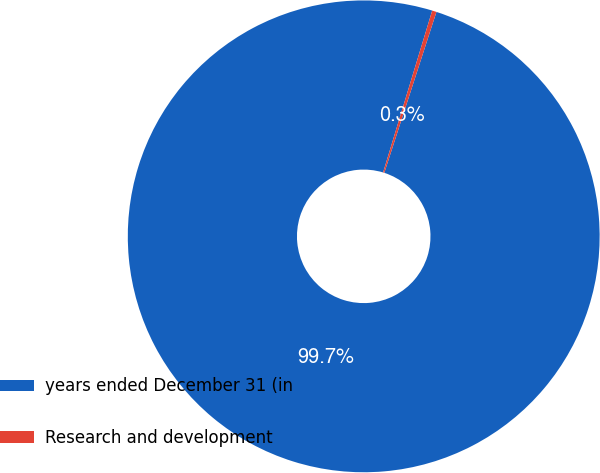Convert chart. <chart><loc_0><loc_0><loc_500><loc_500><pie_chart><fcel>years ended December 31 (in<fcel>Research and development<nl><fcel>99.7%<fcel>0.3%<nl></chart> 